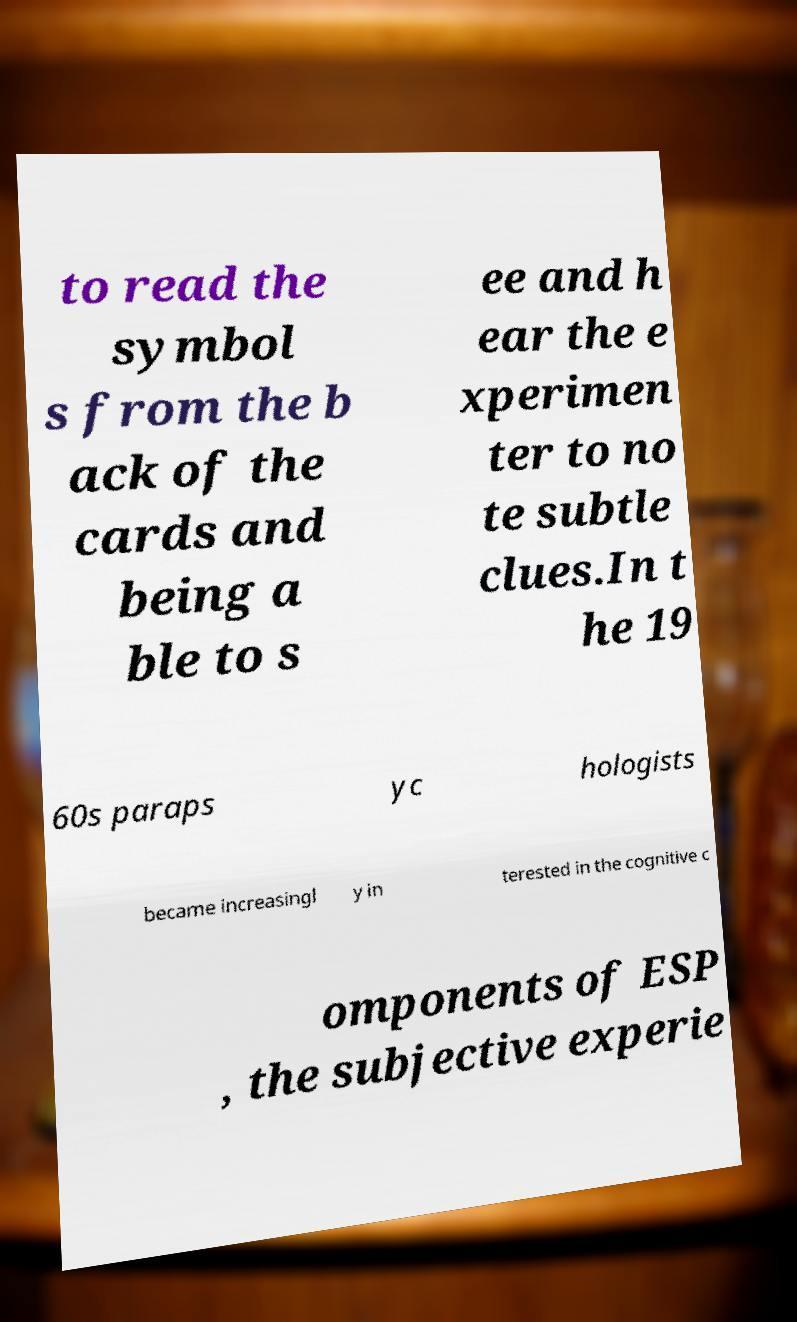Can you accurately transcribe the text from the provided image for me? to read the symbol s from the b ack of the cards and being a ble to s ee and h ear the e xperimen ter to no te subtle clues.In t he 19 60s paraps yc hologists became increasingl y in terested in the cognitive c omponents of ESP , the subjective experie 